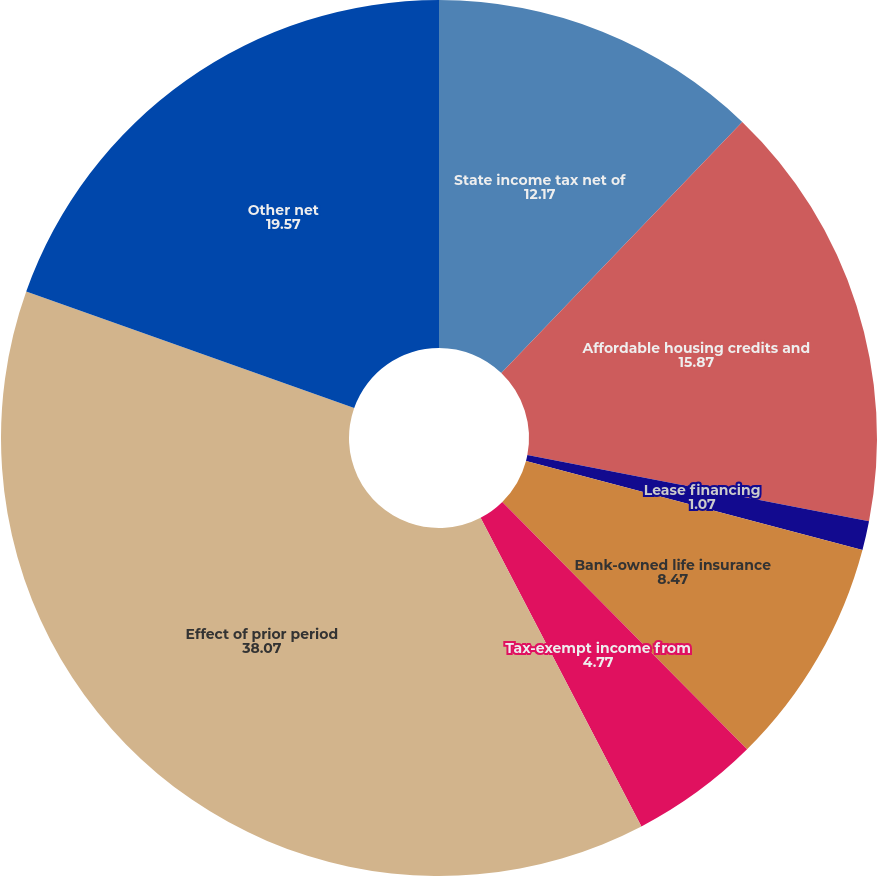<chart> <loc_0><loc_0><loc_500><loc_500><pie_chart><fcel>State income tax net of<fcel>Affordable housing credits and<fcel>Lease financing<fcel>Bank-owned life insurance<fcel>Tax-exempt income from<fcel>Effect of prior period<fcel>Other net<nl><fcel>12.17%<fcel>15.87%<fcel>1.07%<fcel>8.47%<fcel>4.77%<fcel>38.07%<fcel>19.57%<nl></chart> 